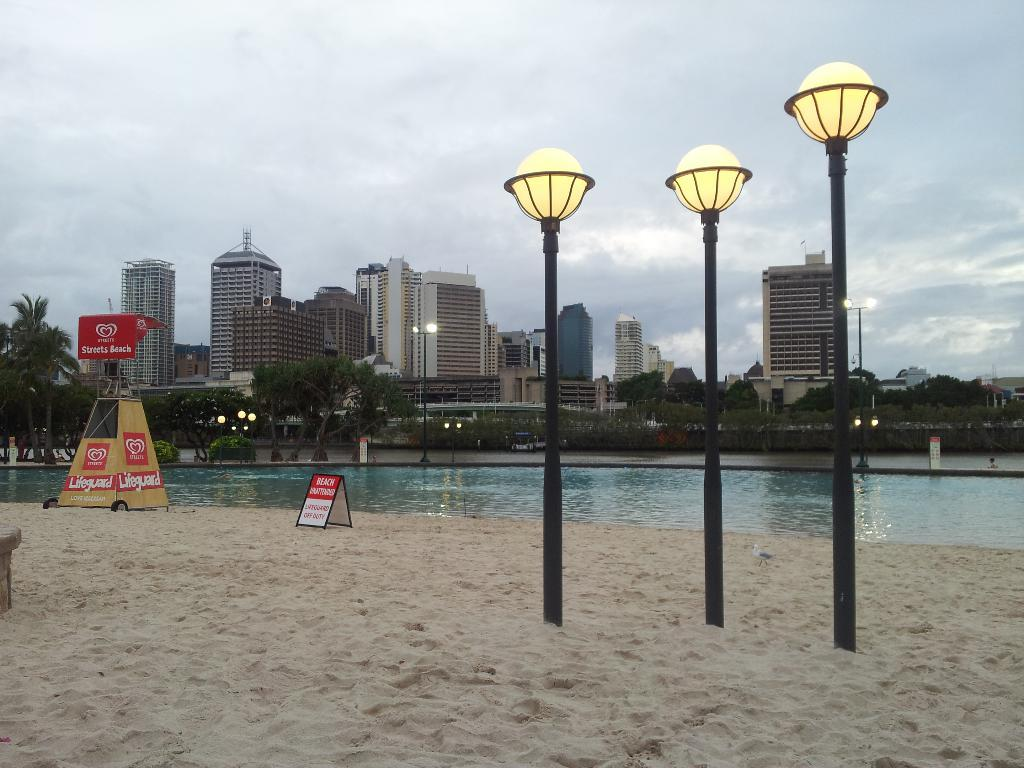What type of structures can be seen in the image? There are poles, boards, and buildings visible in the image. What type of terrain is present in the image? There is sand and water visible in the image. What type of vegetation is present in the image? There are trees in the image. What is visible in the background of the image? The sky is visible in the background of the image, with clouds present. How many stars can be seen in the image? There are no stars visible in the image; it features a landscape with sand, water, trees, and buildings. What type of pen is used to draw the buildings in the image? There is no pen present in the image, as it is a photograph or illustration of a real-life scene. 